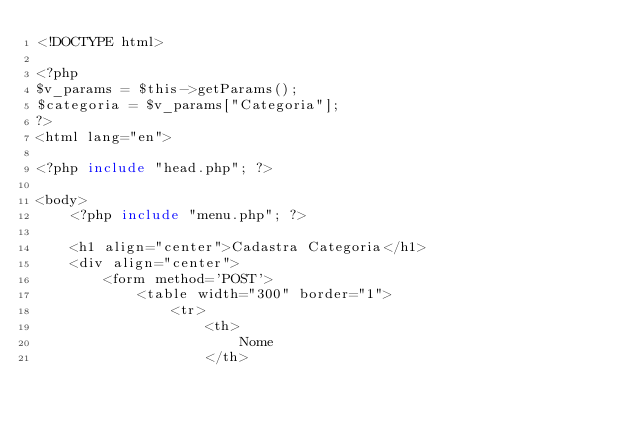Convert code to text. <code><loc_0><loc_0><loc_500><loc_500><_PHP_><!DOCTYPE html>

<?php
$v_params = $this->getParams();
$categoria = $v_params["Categoria"];
?>
<html lang="en">

<?php include "head.php"; ?>

<body>
    <?php include "menu.php"; ?>

    <h1 align="center">Cadastra Categoria</h1>
    <div align="center">
        <form method='POST'>
            <table width="300" border="1">
                <tr>
                    <th>
                        Nome
                    </th>
</code> 